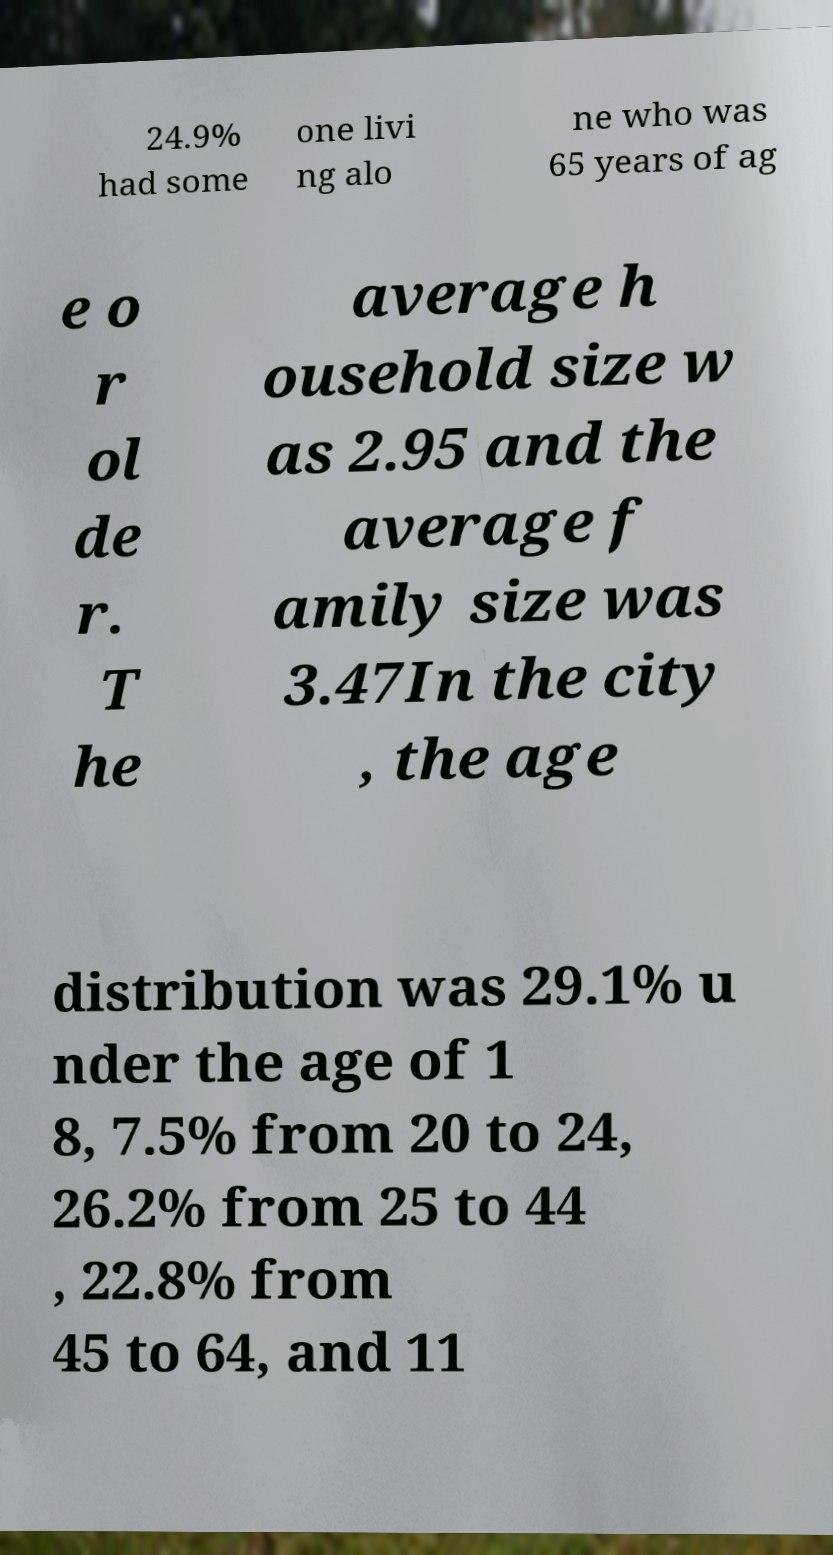There's text embedded in this image that I need extracted. Can you transcribe it verbatim? 24.9% had some one livi ng alo ne who was 65 years of ag e o r ol de r. T he average h ousehold size w as 2.95 and the average f amily size was 3.47In the city , the age distribution was 29.1% u nder the age of 1 8, 7.5% from 20 to 24, 26.2% from 25 to 44 , 22.8% from 45 to 64, and 11 